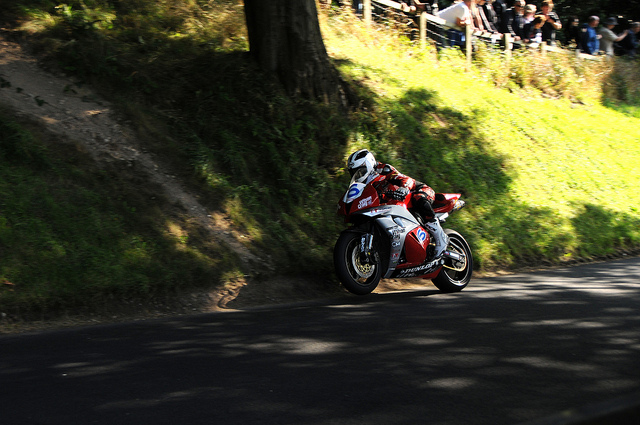Extract all visible text content from this image. 6 S 